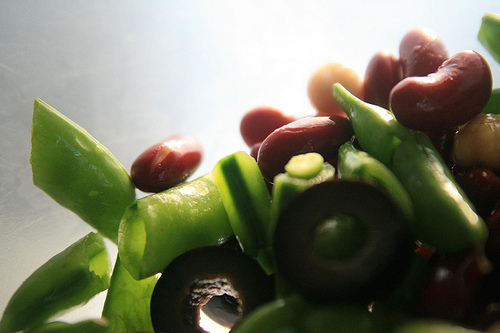<image>
Is the bean to the left of the olive? Yes. From this viewpoint, the bean is positioned to the left side relative to the olive. 